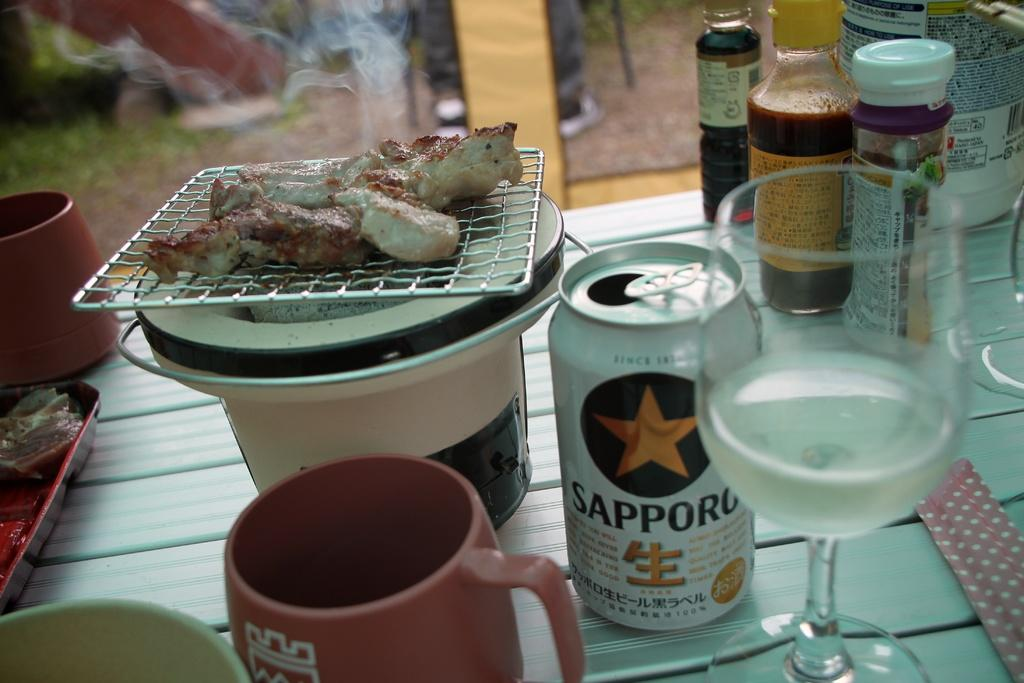Provide a one-sentence caption for the provided image. Barbecued chicken is on a table next to an open can of Sapporo. 